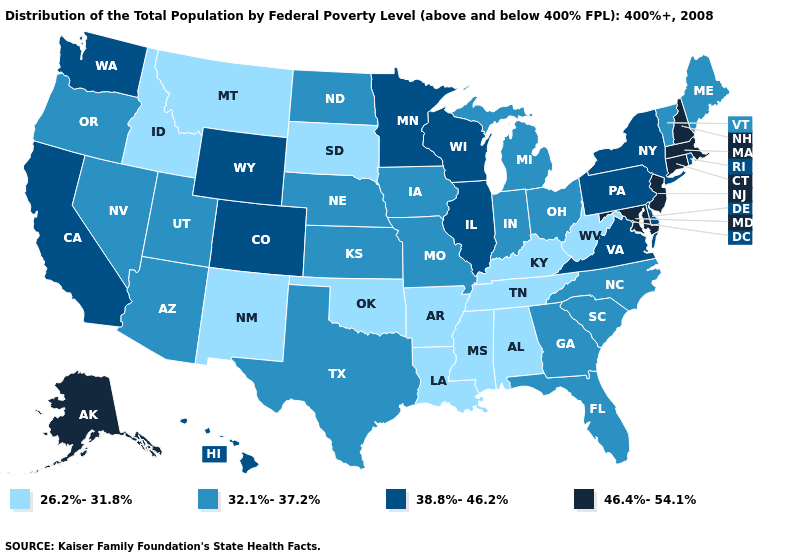Does Wisconsin have the highest value in the MidWest?
Be succinct. Yes. What is the highest value in the USA?
Write a very short answer. 46.4%-54.1%. Does Indiana have the lowest value in the MidWest?
Short answer required. No. Name the states that have a value in the range 32.1%-37.2%?
Write a very short answer. Arizona, Florida, Georgia, Indiana, Iowa, Kansas, Maine, Michigan, Missouri, Nebraska, Nevada, North Carolina, North Dakota, Ohio, Oregon, South Carolina, Texas, Utah, Vermont. Name the states that have a value in the range 46.4%-54.1%?
Give a very brief answer. Alaska, Connecticut, Maryland, Massachusetts, New Hampshire, New Jersey. Name the states that have a value in the range 46.4%-54.1%?
Concise answer only. Alaska, Connecticut, Maryland, Massachusetts, New Hampshire, New Jersey. Does Pennsylvania have a lower value than New Jersey?
Quick response, please. Yes. Does Wisconsin have a lower value than New Hampshire?
Quick response, please. Yes. Name the states that have a value in the range 26.2%-31.8%?
Be succinct. Alabama, Arkansas, Idaho, Kentucky, Louisiana, Mississippi, Montana, New Mexico, Oklahoma, South Dakota, Tennessee, West Virginia. Name the states that have a value in the range 26.2%-31.8%?
Give a very brief answer. Alabama, Arkansas, Idaho, Kentucky, Louisiana, Mississippi, Montana, New Mexico, Oklahoma, South Dakota, Tennessee, West Virginia. What is the highest value in the South ?
Keep it brief. 46.4%-54.1%. What is the lowest value in states that border Kansas?
Concise answer only. 26.2%-31.8%. Is the legend a continuous bar?
Concise answer only. No. Name the states that have a value in the range 38.8%-46.2%?
Concise answer only. California, Colorado, Delaware, Hawaii, Illinois, Minnesota, New York, Pennsylvania, Rhode Island, Virginia, Washington, Wisconsin, Wyoming. Name the states that have a value in the range 38.8%-46.2%?
Short answer required. California, Colorado, Delaware, Hawaii, Illinois, Minnesota, New York, Pennsylvania, Rhode Island, Virginia, Washington, Wisconsin, Wyoming. 